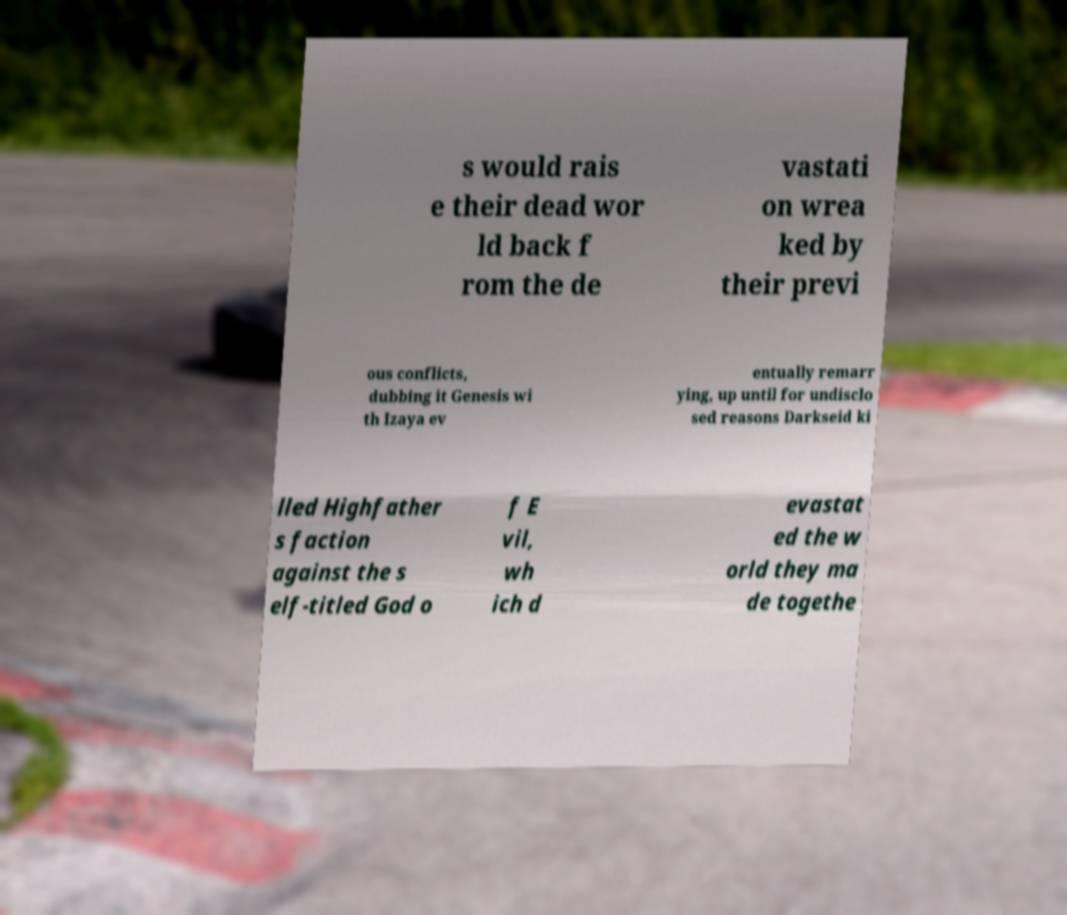Can you read and provide the text displayed in the image?This photo seems to have some interesting text. Can you extract and type it out for me? s would rais e their dead wor ld back f rom the de vastati on wrea ked by their previ ous conflicts, dubbing it Genesis wi th Izaya ev entually remarr ying, up until for undisclo sed reasons Darkseid ki lled Highfather s faction against the s elf-titled God o f E vil, wh ich d evastat ed the w orld they ma de togethe 